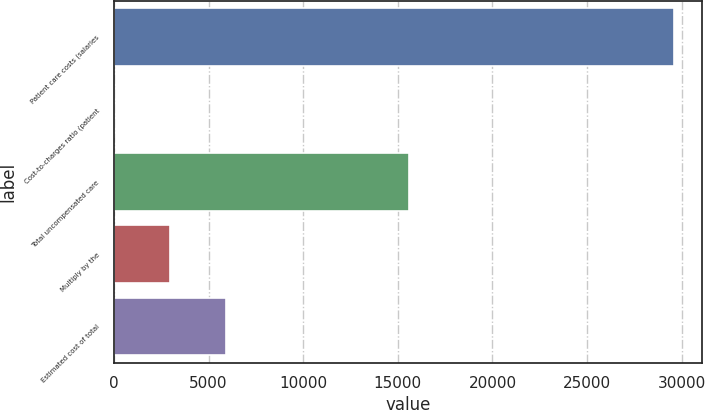Convert chart to OTSL. <chart><loc_0><loc_0><loc_500><loc_500><bar_chart><fcel>Patient care costs (salaries<fcel>Cost-to-charges ratio (patient<fcel>Total uncompensated care<fcel>Multiply by the<fcel>Estimated cost of total<nl><fcel>29606<fcel>16.3<fcel>15565<fcel>2975.27<fcel>5934.24<nl></chart> 